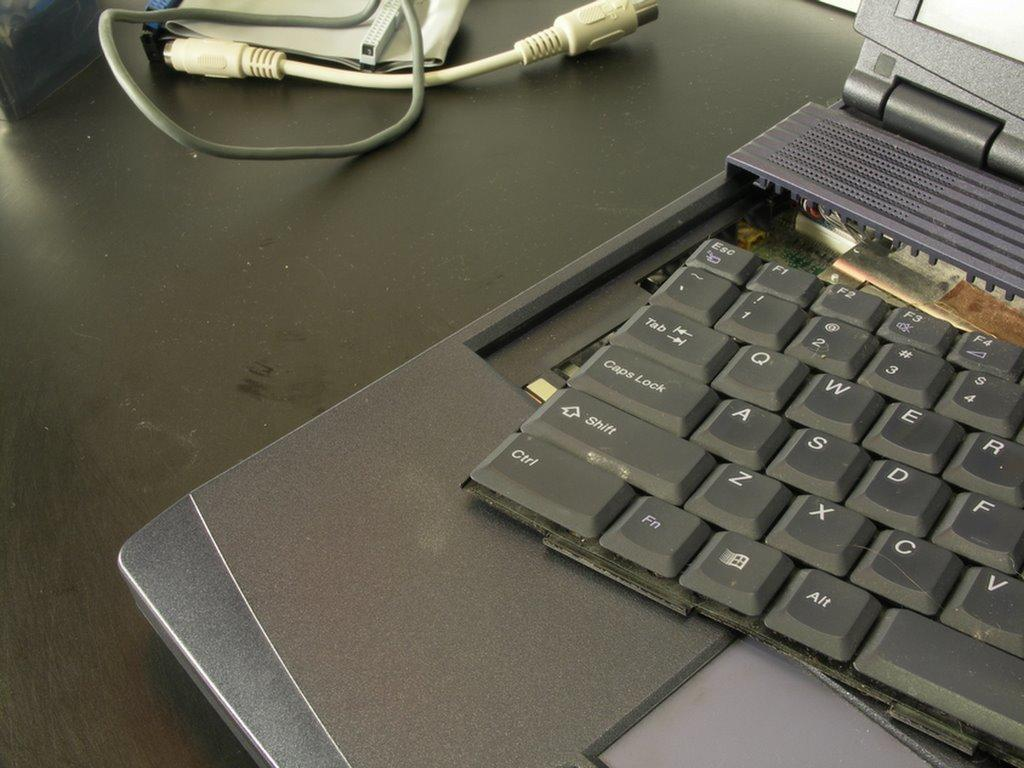<image>
Write a terse but informative summary of the picture. laptop with keyboard pulled out, ctrl, shift, caps lock and other keys visible 